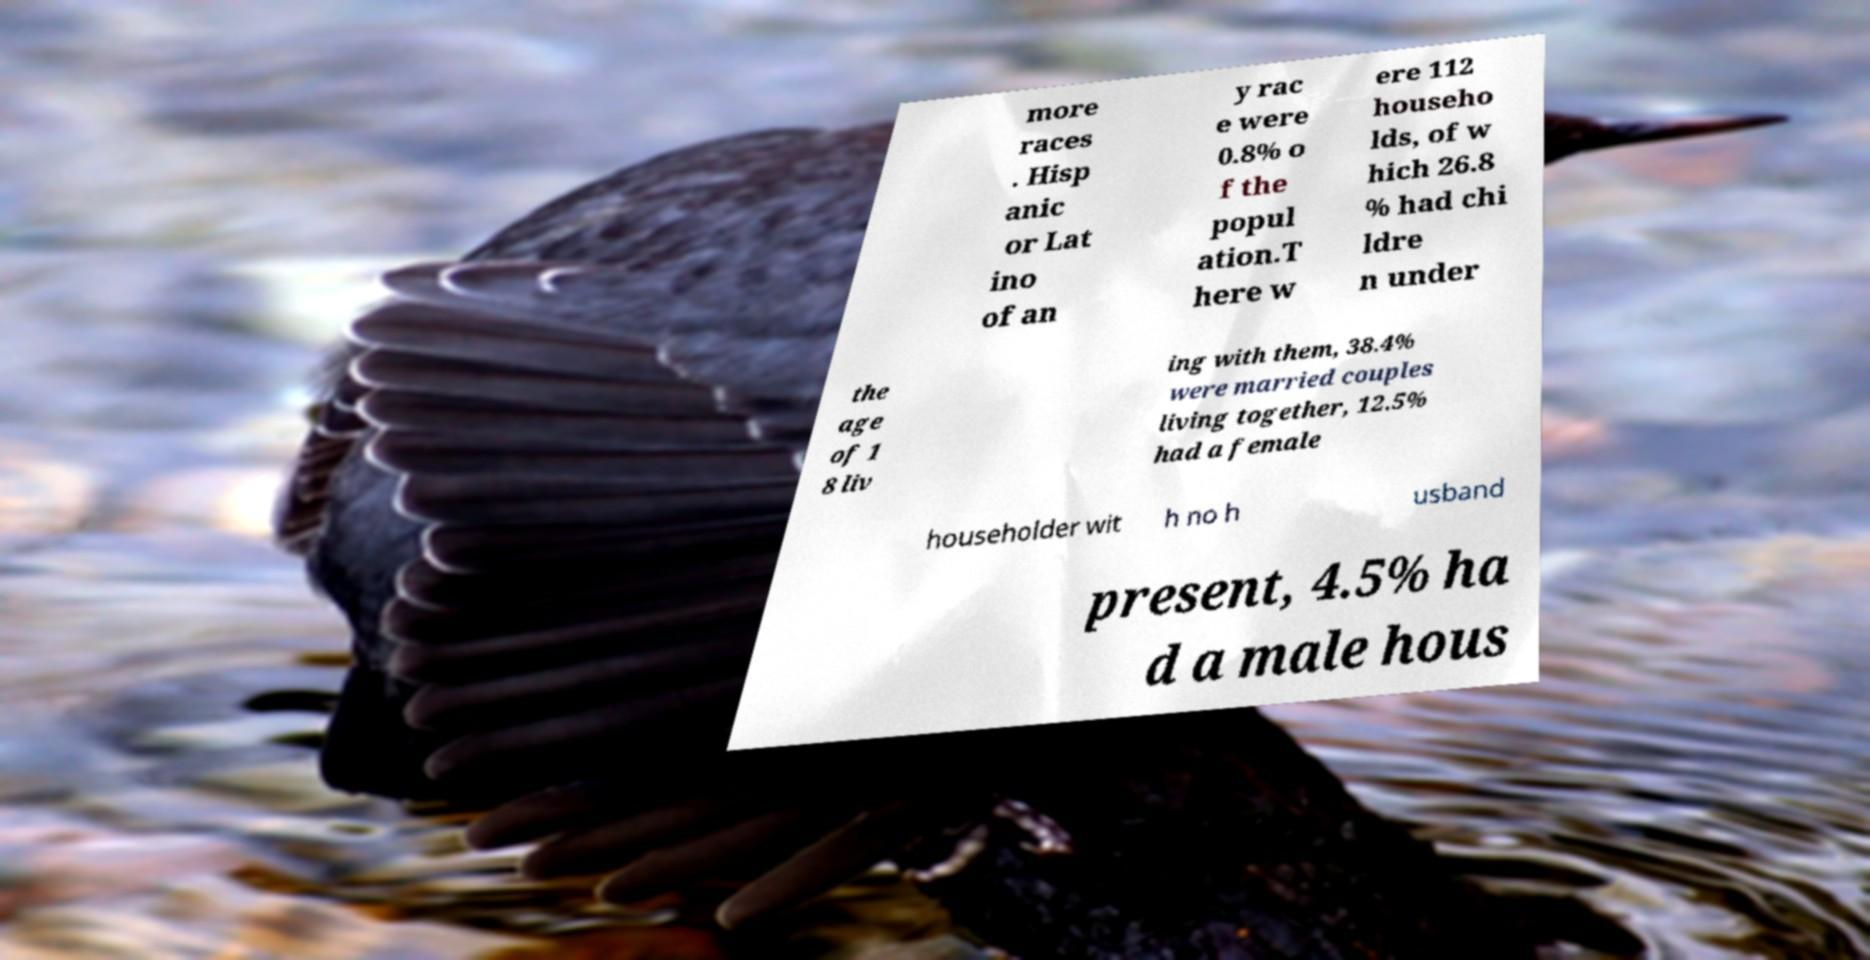I need the written content from this picture converted into text. Can you do that? more races . Hisp anic or Lat ino of an y rac e were 0.8% o f the popul ation.T here w ere 112 househo lds, of w hich 26.8 % had chi ldre n under the age of 1 8 liv ing with them, 38.4% were married couples living together, 12.5% had a female householder wit h no h usband present, 4.5% ha d a male hous 